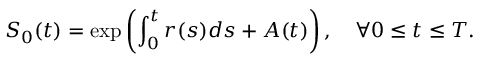Convert formula to latex. <formula><loc_0><loc_0><loc_500><loc_500>S _ { 0 } ( t ) = \exp \left ( \int _ { 0 } ^ { t } r ( s ) d s + A ( t ) \right ) , \quad \forall 0 \leq t \leq T .</formula> 